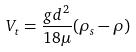<formula> <loc_0><loc_0><loc_500><loc_500>V _ { t } = \frac { g d ^ { 2 } } { 1 8 \mu } ( \rho _ { s } - \rho )</formula> 